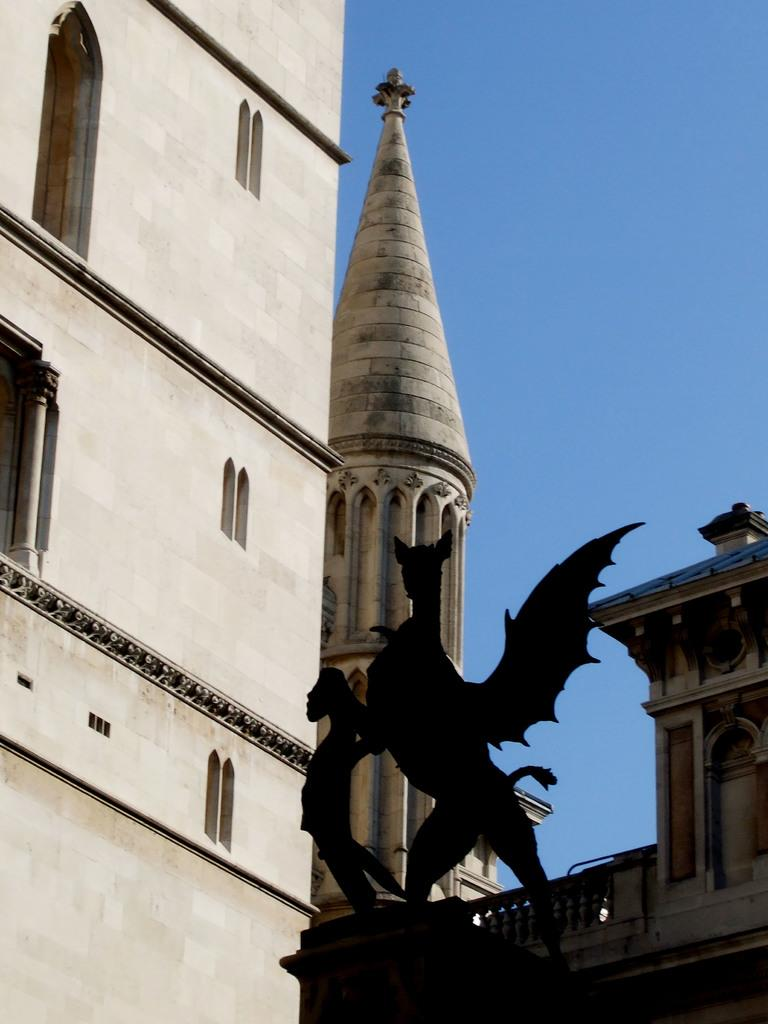What is the main subject in the image? There is a statue in the image. What type of structures can be seen in the image? There are buildings with windows in the image. What can be seen in the background of the image? The sky is visible in the background of the image. What type of ant can be seen crawling on the statue in the image? There are no ants present in the image; it only features a statue, buildings, and the sky. 